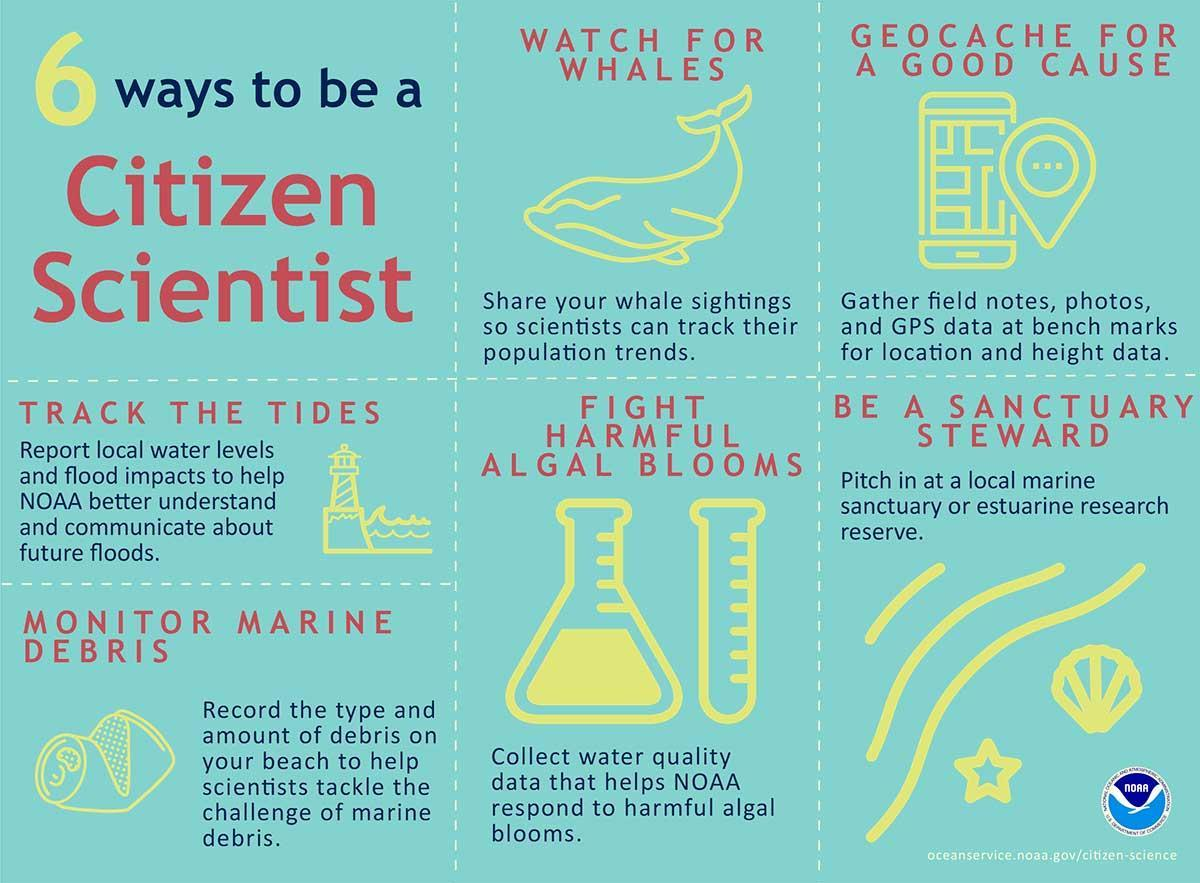what helps NOAA respond to harmful algal blooms
Answer the question with a short phrase. water quality data how can you be a sanctuary steward pitch in at a local marine sanctuary or estuarine research reserve What can you report to track the tides local water levels and flood impacts 